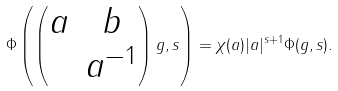Convert formula to latex. <formula><loc_0><loc_0><loc_500><loc_500>\Phi \left ( \left ( \begin{matrix} a & b \\ & a ^ { - 1 } \end{matrix} \right ) g , s \right ) = \chi ( a ) | a | ^ { s + 1 } \Phi ( g , s ) .</formula> 